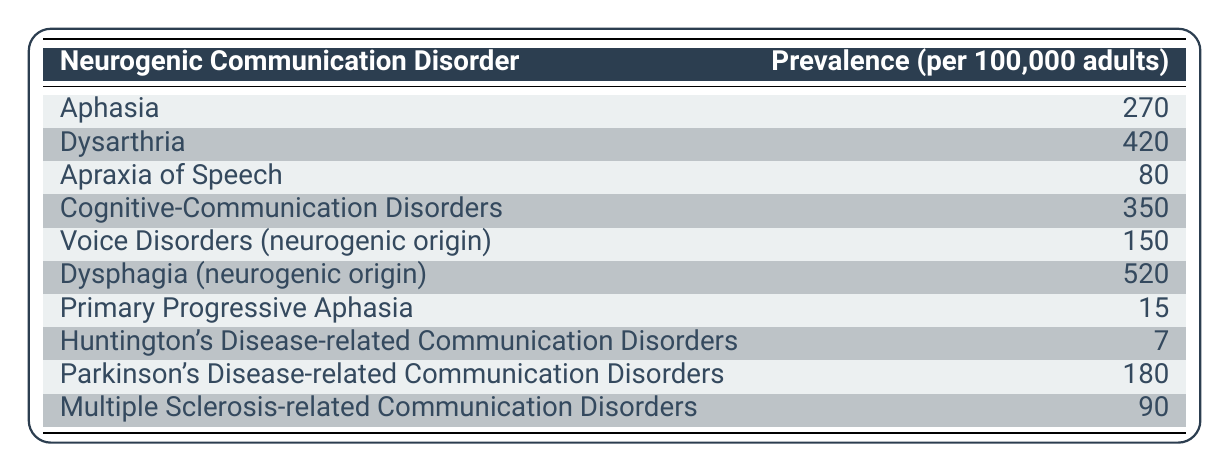What is the prevalence of Dysarthria? Dysarthria is listed in the table with a prevalence value of 420 per 100,000 adults.
Answer: 420 Which neurogenic communication disorder has the highest prevalence? By comparing the values in the table, Dysphagia (neurogenic origin) has the highest prevalence at 520 per 100,000 adults.
Answer: Dysphagia (neurogenic origin) Is the prevalence of Primary Progressive Aphasia greater than 10? The prevalence of Primary Progressive Aphasia is 15, which is greater than 10.
Answer: Yes What is the total prevalence of all listed neurogenic communication disorders? To find the total, we sum all the prevalence values: 270 + 420 + 80 + 350 + 150 + 520 + 15 + 7 + 180 + 90 = 2012.
Answer: 2012 What is the average prevalence of the disorders listed in the table? There are 10 disorders listed in the table, so we calculate the average by dividing the total prevalence (2012) by the number of disorders (10), which is 201.2.
Answer: 201.2 How many disorders have a prevalence of less than 100? Referring to the table, Apraxia of Speech (80), Primary Progressive Aphasia (15), and Huntington's Disease-related Communication Disorders (7) all have a prevalence of less than 100. This totals to 3 disorders.
Answer: 3 Is Dysarthria the only communication disorder listed above 400 prevalence? Checking the values, Dysarthria has a prevalence of 420, and Dysphagia has a value of 520. Thus, Dysarthria is not the only one above 400.
Answer: No Which two disorders have a combined prevalence of 600? By inspecting the table, Cognitive-Communication Disorders (350) and Voice Disorders (neurogenic origin) (150) combine to make 350 + 150 = 500, which is less than 600. This operation must be recalculated with different pairs until we find that Dysarthria (420) and Apraxia of Speech (80) also do not. Thus, no combinations yield 600 exactly. As such, some trials are incorrect.
Answer: No pairs match 600 exactly 